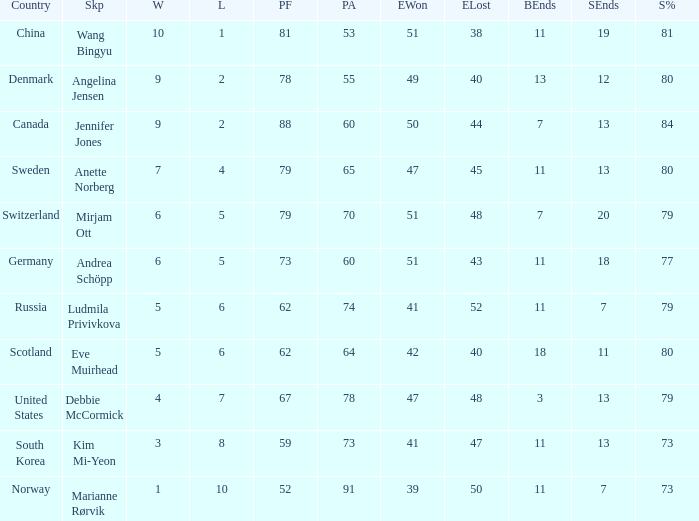What is Norway's least ends lost? 50.0. 